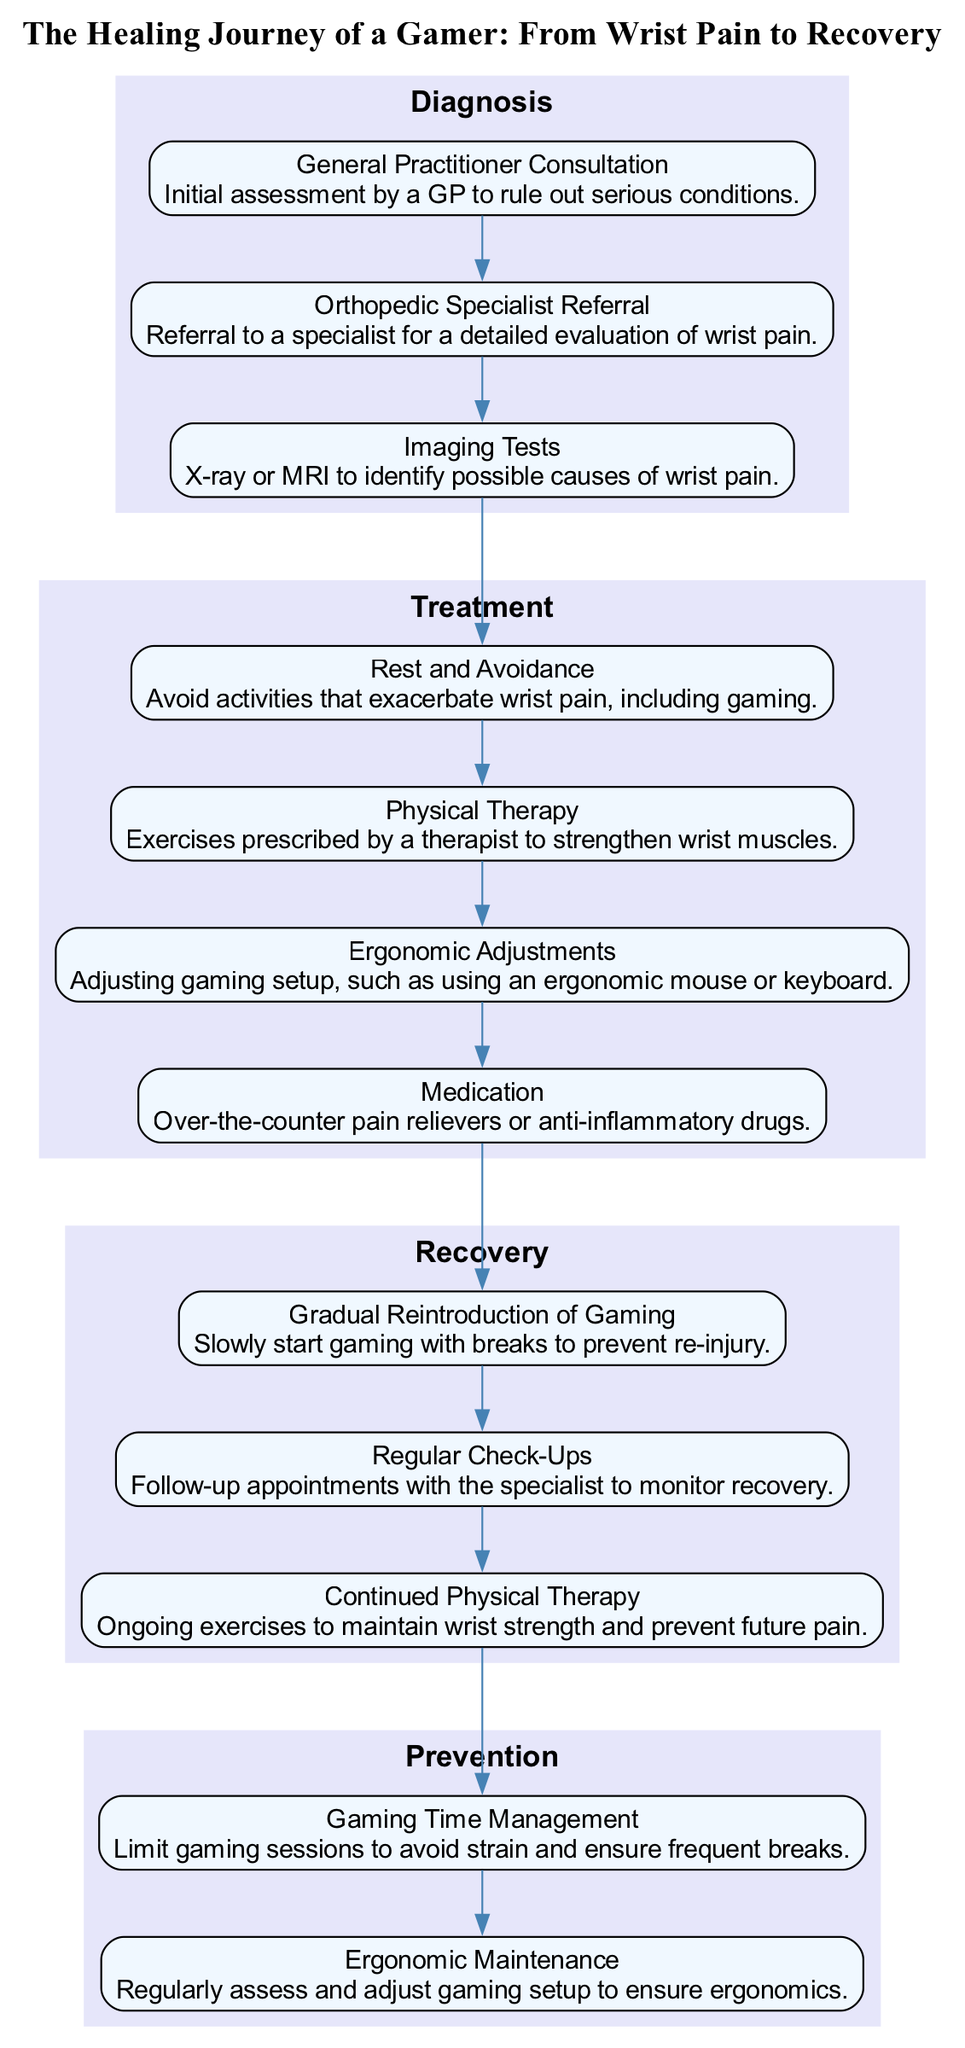What is the first stage in the healing journey? The healing journey begins with the "Diagnosis" stage, as indicated by the diagram layout.
Answer: Diagnosis How many elements are in the Treatment stage? The Treatment stage has four elements listed in the diagram: Rest and Avoidance, Physical Therapy, Ergonomic Adjustments, and Medication.
Answer: 4 What is the last element in the Recovery stage? The last element in the Recovery stage is "Continued Physical Therapy", as shown in the diagram.
Answer: Continued Physical Therapy What are the two prevention measures listed? The diagram specifies two prevention measures: "Gaming Time Management" and "Ergonomic Maintenance".
Answer: Gaming Time Management, Ergonomic Maintenance Which stage comes after Treatment? The stage that follows Treatment is "Recovery," as indicated by the flow of the diagram.
Answer: Recovery What element advises on adjusting gaming setups? The "Ergonomic Adjustments" element provides advice on how to adjust gaming setups for better ergonomics.
Answer: Ergonomic Adjustments How is the relationship between Diagnosis and Treatment stages represented? The diagram connects the Diagnosis stage to the Treatment stage with an edge, indicating a progression from diagnosis to treatment.
Answer: Edge connection Which stage includes Regular Check-Ups? "Recovery" is the stage that includes the element "Regular Check-Ups", as stated in the diagram.
Answer: Recovery 